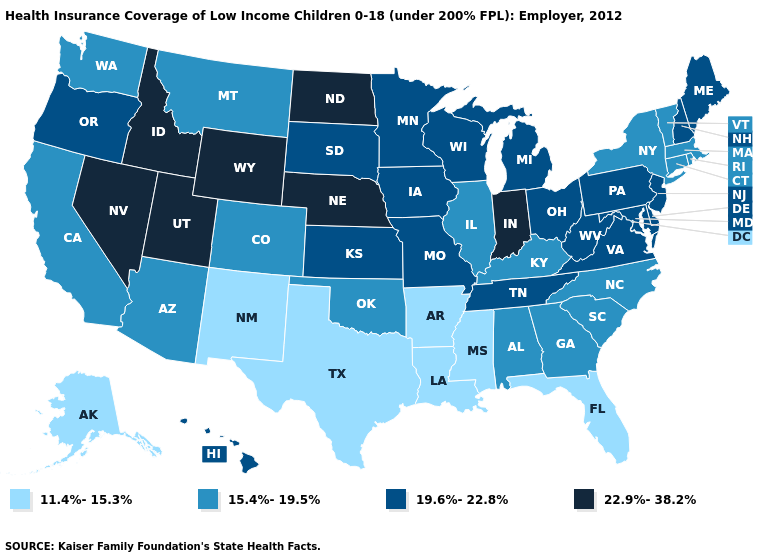What is the highest value in the Northeast ?
Short answer required. 19.6%-22.8%. Among the states that border New Jersey , does Delaware have the highest value?
Give a very brief answer. Yes. What is the lowest value in the USA?
Answer briefly. 11.4%-15.3%. Does Pennsylvania have the lowest value in the USA?
Give a very brief answer. No. Name the states that have a value in the range 22.9%-38.2%?
Concise answer only. Idaho, Indiana, Nebraska, Nevada, North Dakota, Utah, Wyoming. Does the map have missing data?
Be succinct. No. Among the states that border Washington , does Idaho have the lowest value?
Concise answer only. No. Among the states that border Mississippi , which have the lowest value?
Concise answer only. Arkansas, Louisiana. Which states have the lowest value in the USA?
Keep it brief. Alaska, Arkansas, Florida, Louisiana, Mississippi, New Mexico, Texas. Does Iowa have the lowest value in the USA?
Write a very short answer. No. What is the lowest value in states that border Connecticut?
Answer briefly. 15.4%-19.5%. What is the value of Hawaii?
Write a very short answer. 19.6%-22.8%. Which states hav the highest value in the MidWest?
Be succinct. Indiana, Nebraska, North Dakota. What is the highest value in states that border New York?
Write a very short answer. 19.6%-22.8%. Name the states that have a value in the range 19.6%-22.8%?
Answer briefly. Delaware, Hawaii, Iowa, Kansas, Maine, Maryland, Michigan, Minnesota, Missouri, New Hampshire, New Jersey, Ohio, Oregon, Pennsylvania, South Dakota, Tennessee, Virginia, West Virginia, Wisconsin. 